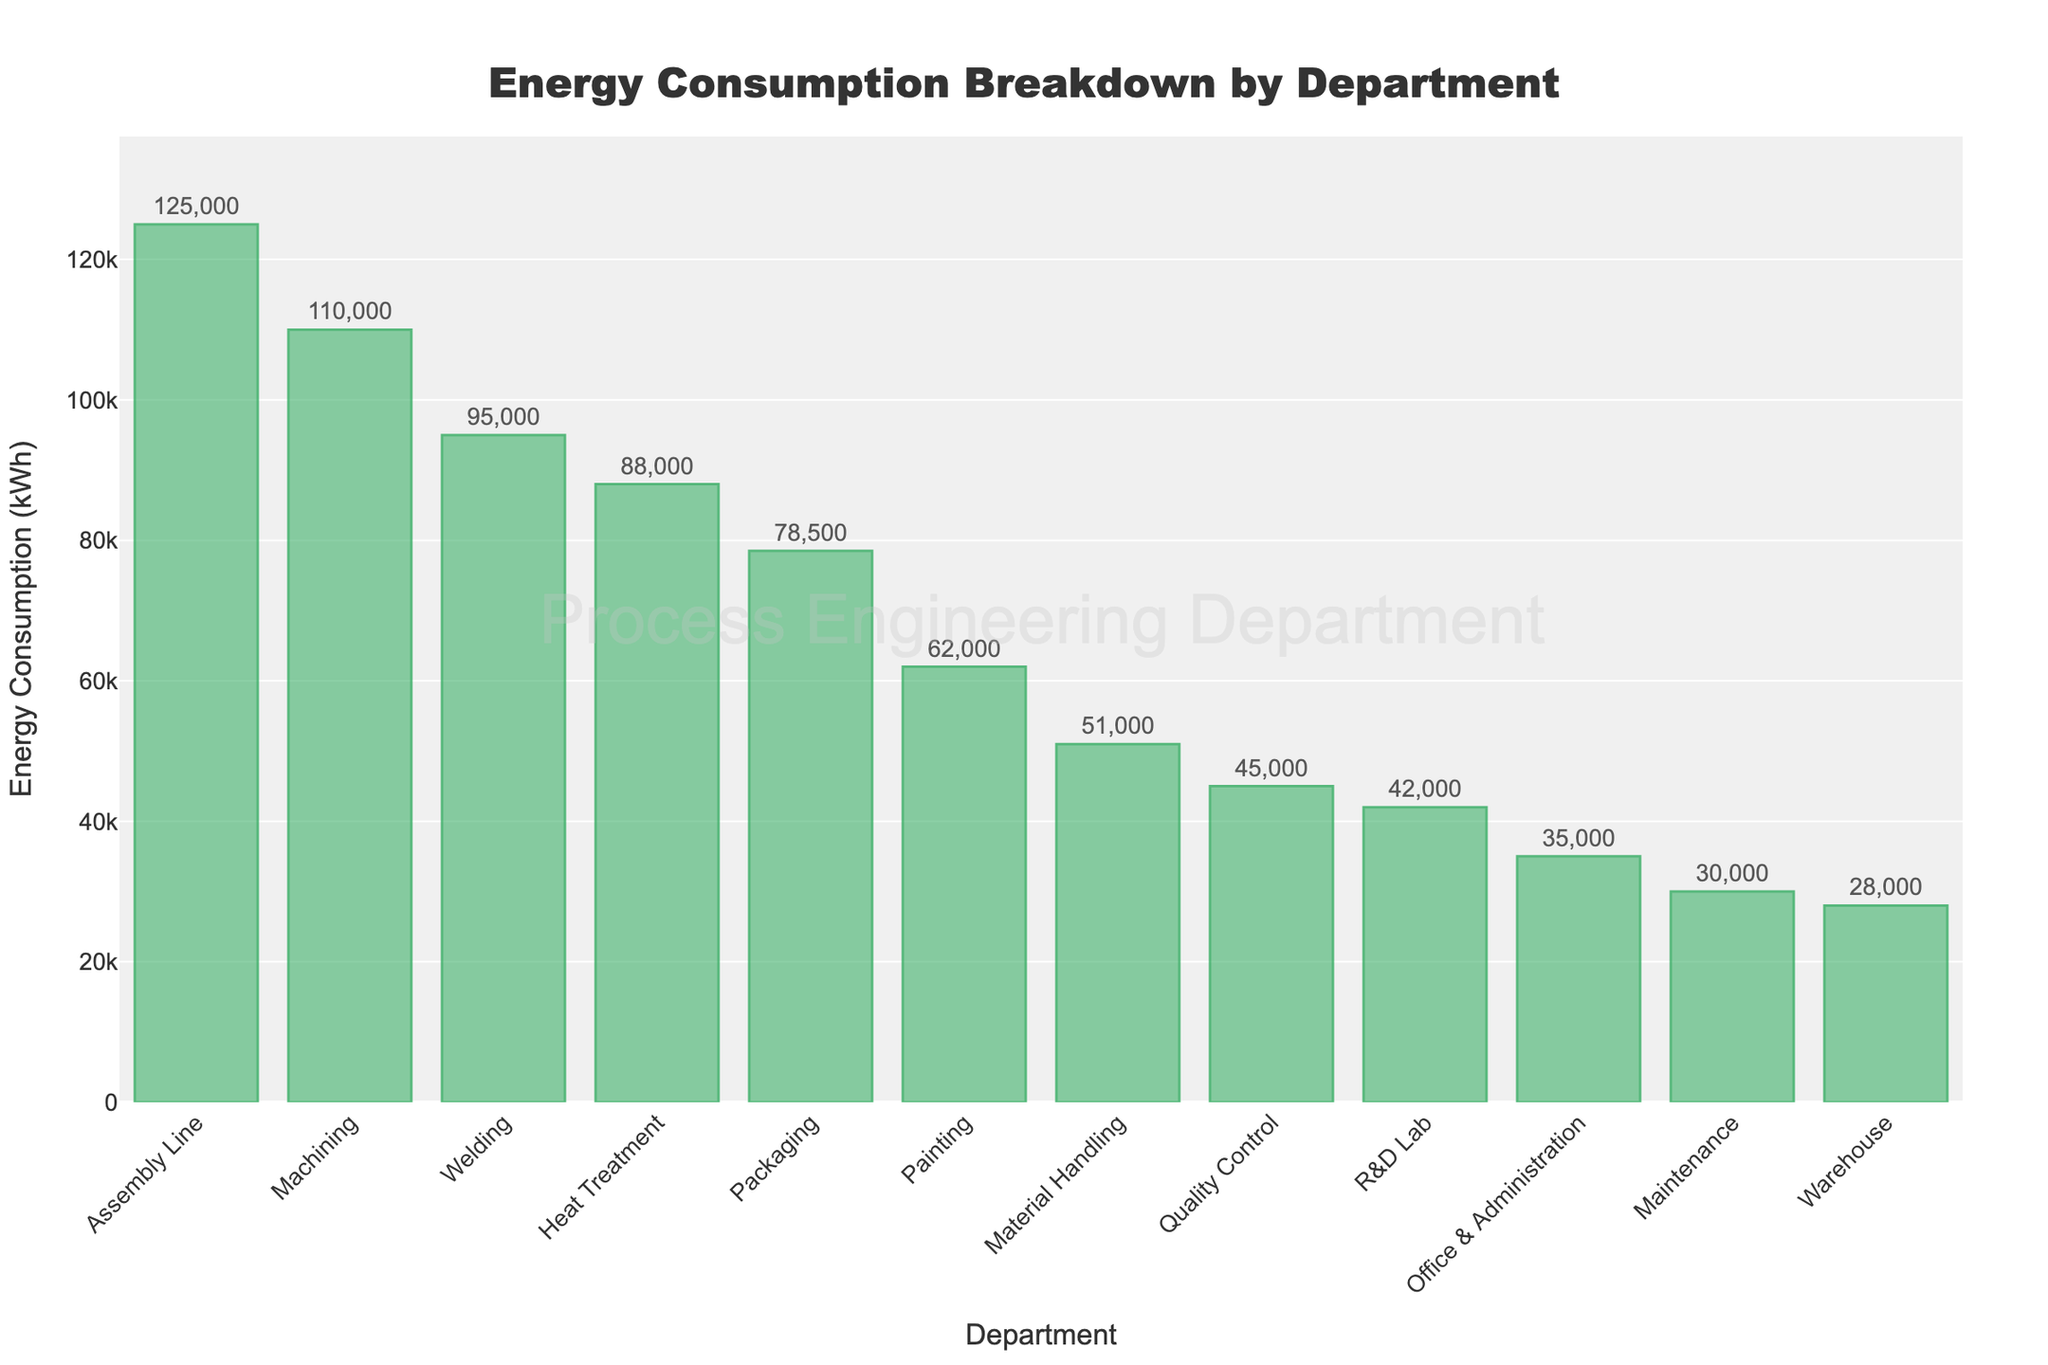What's the department with the highest energy consumption? The bar representing the Assembly Line department is the tallest, indicating that it has the highest energy consumption.
Answer: Assembly Line What's the difference in energy consumption between the Assembly Line and Quality Control departments? The Assembly Line department consumes 125,000 kWh, and the Quality Control department consumes 45,000 kWh. The difference is 125,000 kWh - 45,000 kWh.
Answer: 80,000 kWh Which department uses less energy: R&D Lab or Office & Administration? By comparing the height of the bars, the R&D Lab consumes 42,000 kWh, while Office & Administration consumes 35,000 kWh.
Answer: Office & Administration What is the total energy consumption of Machining, Welding, and Heat Treatment departments combined? Add the energy consumption of Machining (110,000 kWh), Welding (95,000 kWh), and Heat Treatment (88,000 kWh).
Answer: 293,000 kWh How much more energy does Material Handling consume compared to Maintenance? Material Handling consumes 51,000 kWh, and Maintenance consumes 30,000 kWh. The difference is 51,000 kWh - 30,000 kWh.
Answer: 21,000 kWh What proportion of the total energy consumption is used by the Painting department? The Painting department uses 62,000 kWh. Sum up all departments’ consumption and calculate the proportion: 62,000 / (total sum of energy consumption).
Answer: Approx. 9.4% Is the energy consumption of the Welding department greater than the combined consumption of the Office & Administration and Warehouse departments? The Welding department consumes 95,000 kWh. The combined consumption of Office & Administration (35,000 kWh) and Warehouse (28,000 kWh) is 63,000 kWh.
Answer: Yes Which bar is the shortest in the figure? The bar representing the Warehouse department is the shortest.
Answer: Warehouse What is the average energy consumption of all departments? Sum all the energy consumption values and divide by the number of departments (12): (Sum of all values) / 12.
Answer: Approx. 64,250 kWh How many departments have energy consumption higher than 80,000 kWh? Identify and count departments with energy consumption greater than 80,000 kWh: Assembly Line, Machining, Welding, and Heat Treatment.
Answer: 4 